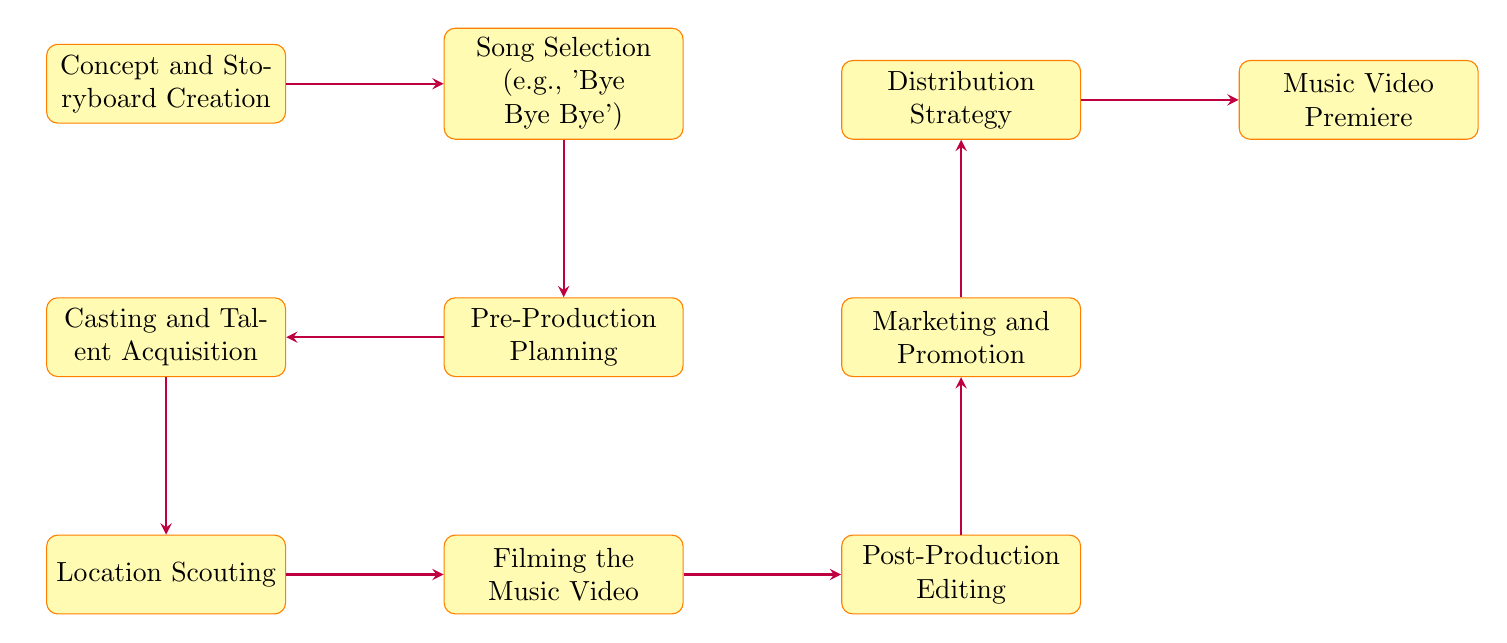What is the first step in the music video release strategy? The first step is indicated by the initial node in the diagram, which is "Concept and Storyboard Creation."
Answer: Concept and Storyboard Creation How many main steps are there in total? By counting all the nodes in the diagram, we find there are ten steps.
Answer: Ten Which step follows "Song Selection"? The diagram shows that "Pre-Production Planning" is the step that comes after "Song Selection."
Answer: Pre-Production Planning What comes directly after "Post-Production Editing"? The direct successor to "Post-Production Editing" in the flow is "Marketing and Promotion."
Answer: Marketing and Promotion What is the final step in the music video release strategy? The last node in the diagram denotes the completion of the process, which is "Music Video Premiere."
Answer: Music Video Premiere If "Casting and Talent Acquisition" is completed, what is the next step? The diagram illustrates that following "Casting and Talent Acquisition," the next task is "Location Scouting."
Answer: Location Scouting What two steps are directly connected to "Filming the Music Video"? The nodes connected to "Filming the Music Video" are "Location Scouting" (before it) and "Post-Production Editing" (after it).
Answer: Location Scouting, Post-Production Editing Which two steps are at the end of the release strategy before the premiere? The last two steps before the premiere in the flow are "Distribution Strategy" and "Music Video Premiere."
Answer: Distribution Strategy, Music Video Premiere What is the relationship between "Pre-Production Planning" and "Casting and Talent Acquisition"? The diagram shows that "Casting and Talent Acquisition" directly follows "Pre-Production Planning," indicating a sequential relationship.
Answer: Sequential relationship 